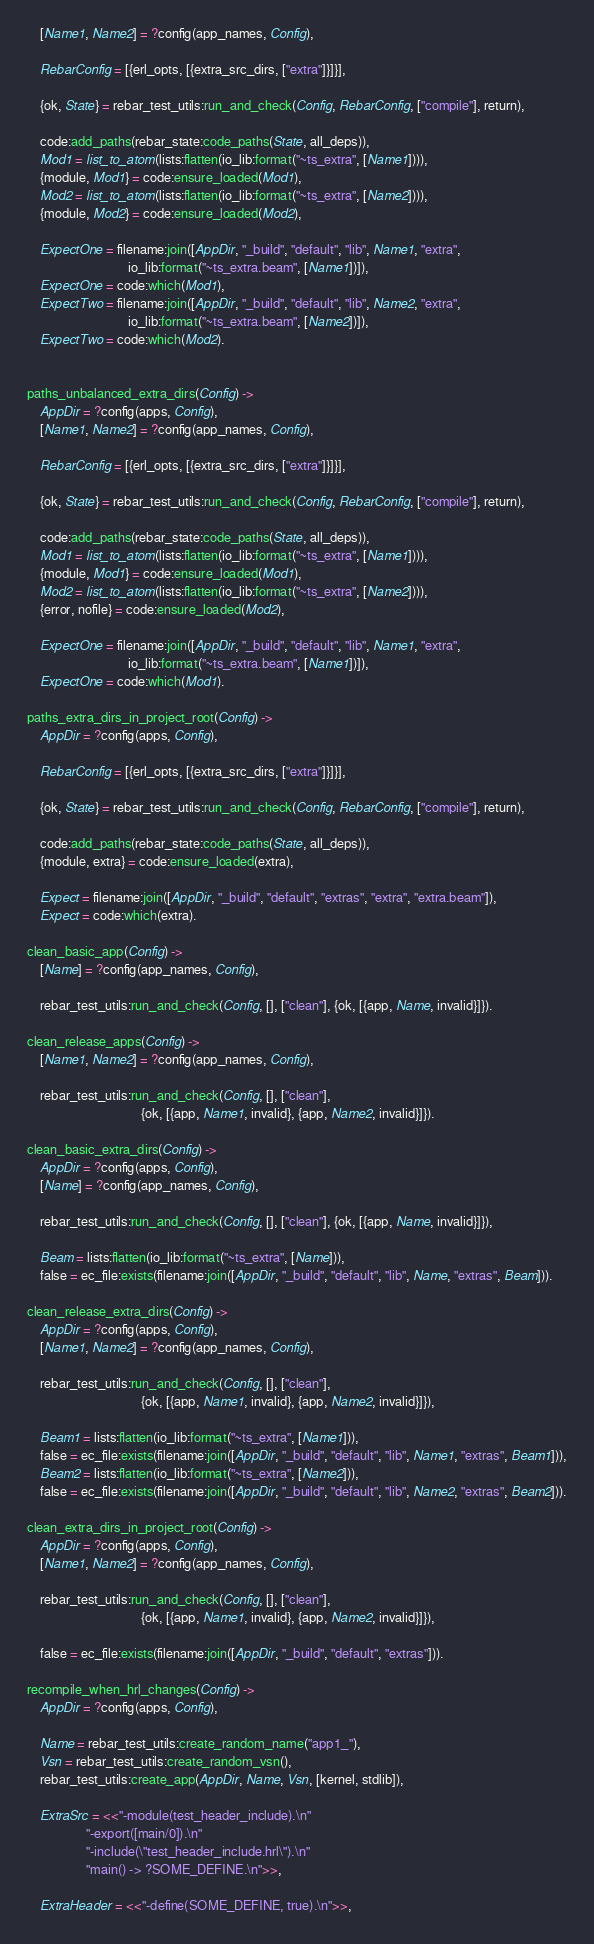Convert code to text. <code><loc_0><loc_0><loc_500><loc_500><_Erlang_>    [Name1, Name2] = ?config(app_names, Config),

    RebarConfig = [{erl_opts, [{extra_src_dirs, ["extra"]}]}],

    {ok, State} = rebar_test_utils:run_and_check(Config, RebarConfig, ["compile"], return),

    code:add_paths(rebar_state:code_paths(State, all_deps)),
    Mod1 = list_to_atom(lists:flatten(io_lib:format("~ts_extra", [Name1]))),
    {module, Mod1} = code:ensure_loaded(Mod1),
    Mod2 = list_to_atom(lists:flatten(io_lib:format("~ts_extra", [Name2]))),
    {module, Mod2} = code:ensure_loaded(Mod2),

    ExpectOne = filename:join([AppDir, "_build", "default", "lib", Name1, "extra",
                               io_lib:format("~ts_extra.beam", [Name1])]),
    ExpectOne = code:which(Mod1),
    ExpectTwo = filename:join([AppDir, "_build", "default", "lib", Name2, "extra",
                               io_lib:format("~ts_extra.beam", [Name2])]),
    ExpectTwo = code:which(Mod2).


paths_unbalanced_extra_dirs(Config) ->
    AppDir = ?config(apps, Config),
    [Name1, Name2] = ?config(app_names, Config),

    RebarConfig = [{erl_opts, [{extra_src_dirs, ["extra"]}]}],

    {ok, State} = rebar_test_utils:run_and_check(Config, RebarConfig, ["compile"], return),

    code:add_paths(rebar_state:code_paths(State, all_deps)),
    Mod1 = list_to_atom(lists:flatten(io_lib:format("~ts_extra", [Name1]))),
    {module, Mod1} = code:ensure_loaded(Mod1),
    Mod2 = list_to_atom(lists:flatten(io_lib:format("~ts_extra", [Name2]))),
    {error, nofile} = code:ensure_loaded(Mod2),

    ExpectOne = filename:join([AppDir, "_build", "default", "lib", Name1, "extra",
                               io_lib:format("~ts_extra.beam", [Name1])]),
    ExpectOne = code:which(Mod1).

paths_extra_dirs_in_project_root(Config) ->
    AppDir = ?config(apps, Config),

    RebarConfig = [{erl_opts, [{extra_src_dirs, ["extra"]}]}],

    {ok, State} = rebar_test_utils:run_and_check(Config, RebarConfig, ["compile"], return),

    code:add_paths(rebar_state:code_paths(State, all_deps)),
    {module, extra} = code:ensure_loaded(extra),

    Expect = filename:join([AppDir, "_build", "default", "extras", "extra", "extra.beam"]),
    Expect = code:which(extra).

clean_basic_app(Config) ->
    [Name] = ?config(app_names, Config),

    rebar_test_utils:run_and_check(Config, [], ["clean"], {ok, [{app, Name, invalid}]}).

clean_release_apps(Config) ->
    [Name1, Name2] = ?config(app_names, Config),

    rebar_test_utils:run_and_check(Config, [], ["clean"],
                                   {ok, [{app, Name1, invalid}, {app, Name2, invalid}]}).

clean_basic_extra_dirs(Config) ->
    AppDir = ?config(apps, Config),
    [Name] = ?config(app_names, Config),

    rebar_test_utils:run_and_check(Config, [], ["clean"], {ok, [{app, Name, invalid}]}),

    Beam = lists:flatten(io_lib:format("~ts_extra", [Name])),
    false = ec_file:exists(filename:join([AppDir, "_build", "default", "lib", Name, "extras", Beam])).

clean_release_extra_dirs(Config) ->
    AppDir = ?config(apps, Config),
    [Name1, Name2] = ?config(app_names, Config),

    rebar_test_utils:run_and_check(Config, [], ["clean"],
                                   {ok, [{app, Name1, invalid}, {app, Name2, invalid}]}),

    Beam1 = lists:flatten(io_lib:format("~ts_extra", [Name1])),
    false = ec_file:exists(filename:join([AppDir, "_build", "default", "lib", Name1, "extras", Beam1])),
    Beam2 = lists:flatten(io_lib:format("~ts_extra", [Name2])),
    false = ec_file:exists(filename:join([AppDir, "_build", "default", "lib", Name2, "extras", Beam2])).

clean_extra_dirs_in_project_root(Config) ->
    AppDir = ?config(apps, Config),
    [Name1, Name2] = ?config(app_names, Config),

    rebar_test_utils:run_and_check(Config, [], ["clean"],
                                   {ok, [{app, Name1, invalid}, {app, Name2, invalid}]}),

    false = ec_file:exists(filename:join([AppDir, "_build", "default", "extras"])).

recompile_when_hrl_changes(Config) ->
    AppDir = ?config(apps, Config),

    Name = rebar_test_utils:create_random_name("app1_"),
    Vsn = rebar_test_utils:create_random_vsn(),
    rebar_test_utils:create_app(AppDir, Name, Vsn, [kernel, stdlib]),

    ExtraSrc = <<"-module(test_header_include).\n"
                  "-export([main/0]).\n"
                  "-include(\"test_header_include.hrl\").\n"
                  "main() -> ?SOME_DEFINE.\n">>,

    ExtraHeader = <<"-define(SOME_DEFINE, true).\n">>,</code> 